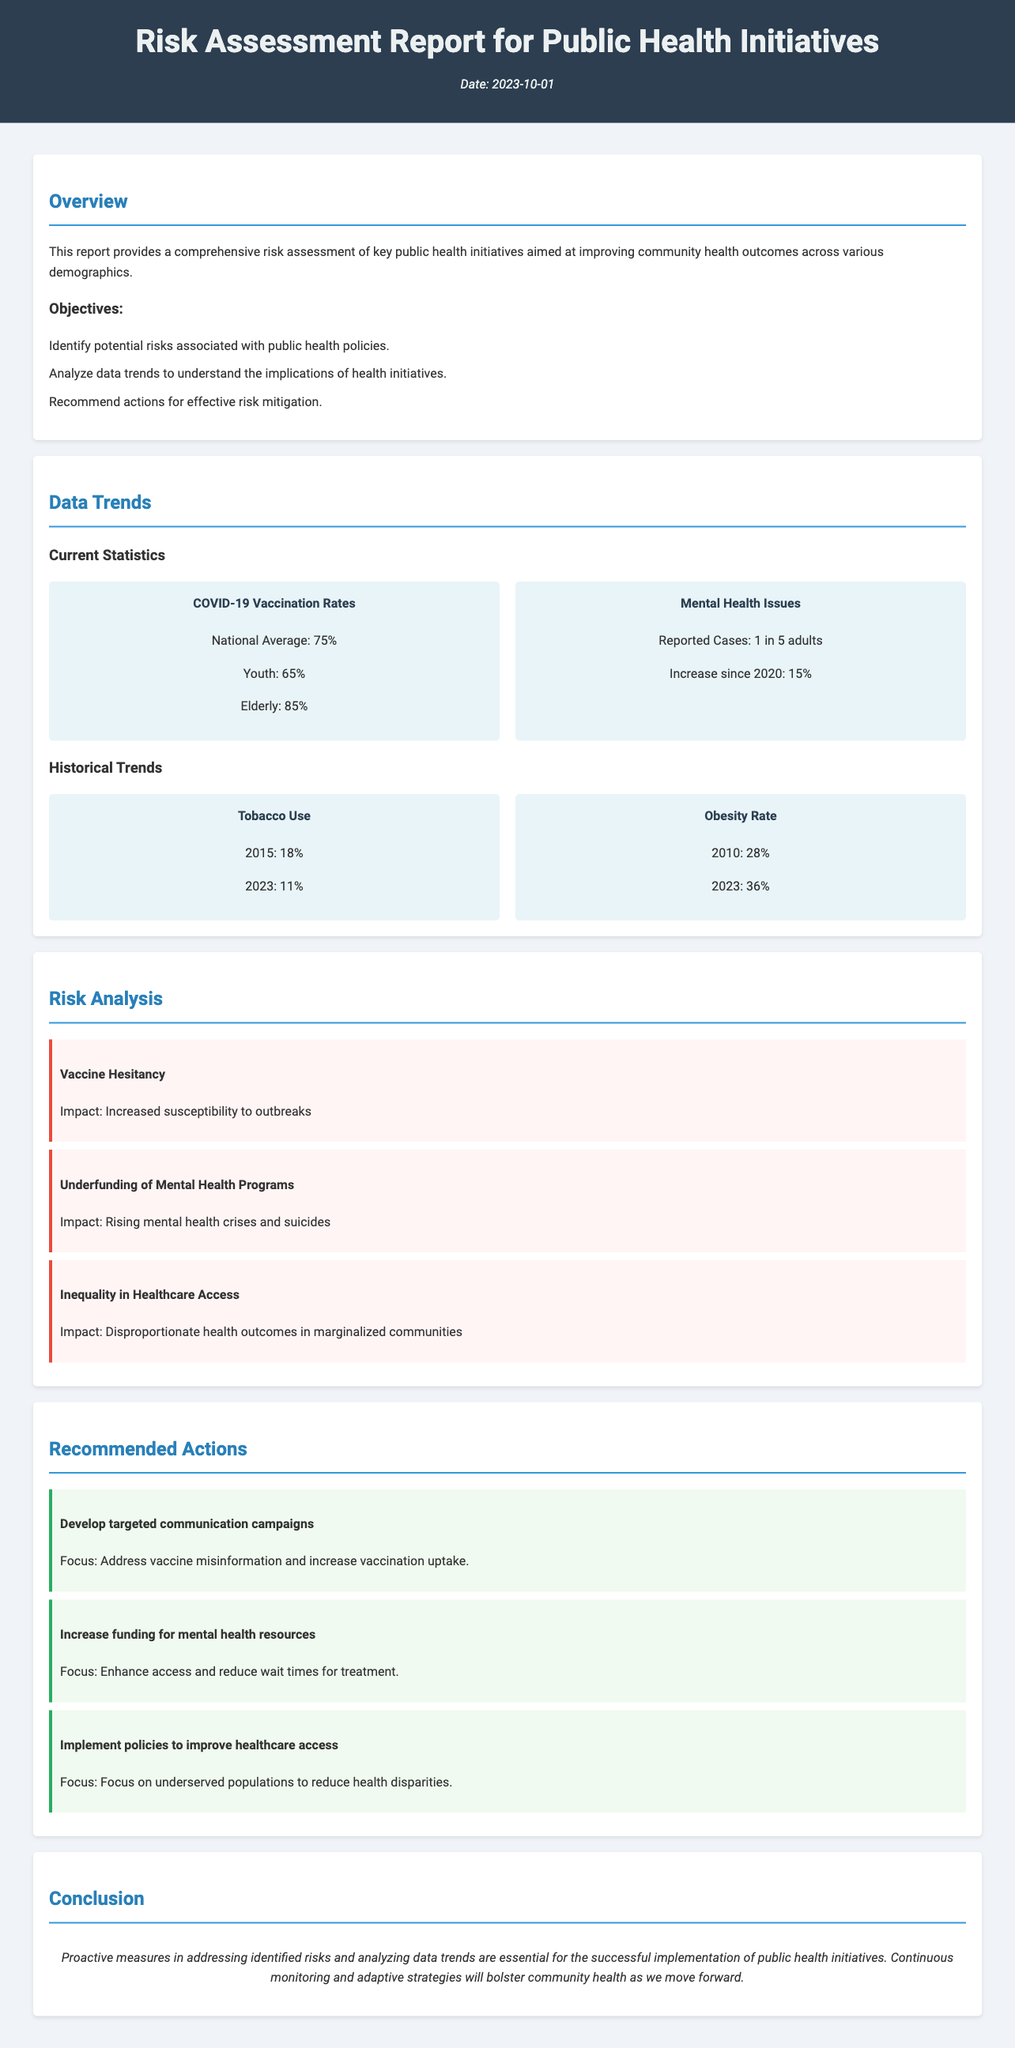What is the date of the report? The date is explicitly mentioned in the header section of the document.
Answer: 2023-10-01 What percentage of the national average vaccination rates is reported? The document provides a statistic related to COVID-19 vaccination rates.
Answer: 75% What is the reported percentage increase in mental health issues since 2020? The document states a specific increase related to mental health issues.
Answer: 15% What was the obesity rate in 2010? The historical trend for obesity rate is documented, providing specific figures for years.
Answer: 28% What is the impact of vaccine hesitancy? The risks section outlines the specific impact of identified risks.
Answer: Increased susceptibility to outbreaks What is one of the recommended actions to address underfunding of mental health programs? The document lists specific recommended actions related to identified risks.
Answer: Increase funding for mental health resources Which demographic has the lowest COVID-19 vaccination rate according to the report? The report breaks down COVID-19 vaccination rates by age groups.
Answer: Youth How many adults are reported to have mental health issues? The document provides a statistic regarding mental health issues among adults.
Answer: 1 in 5 adults What healthcare issue is highlighted in the risk analysis regarding marginalized communities? The risks section discusses specific inequalities related to healthcare access.
Answer: Inequality in Healthcare Access 